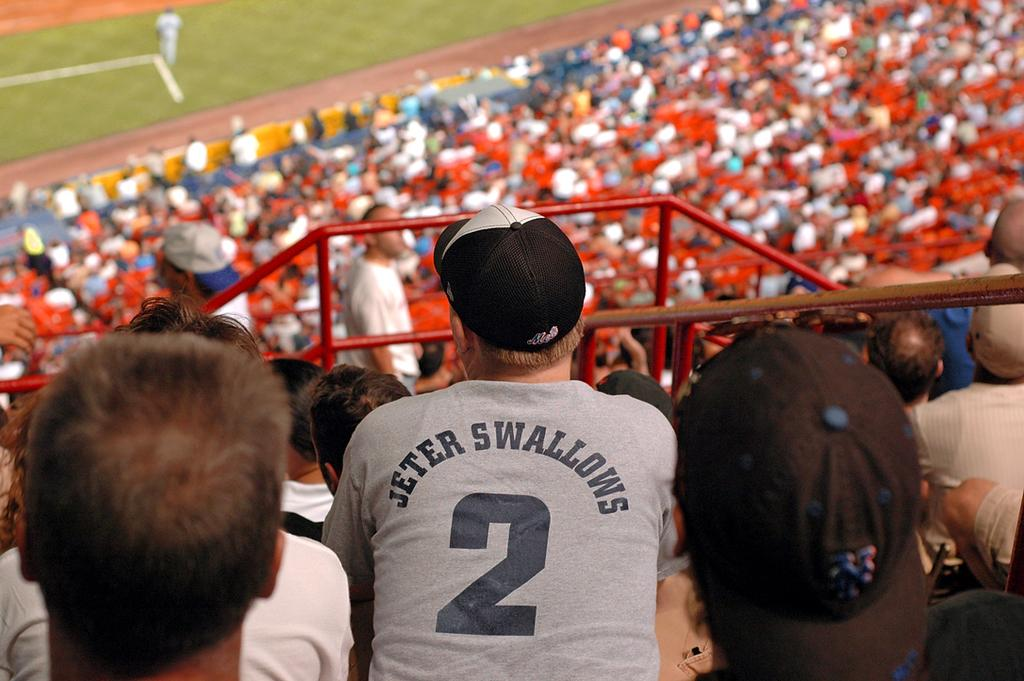<image>
Provide a brief description of the given image. man sitting in the stands wearing a jeter swallows shirt 